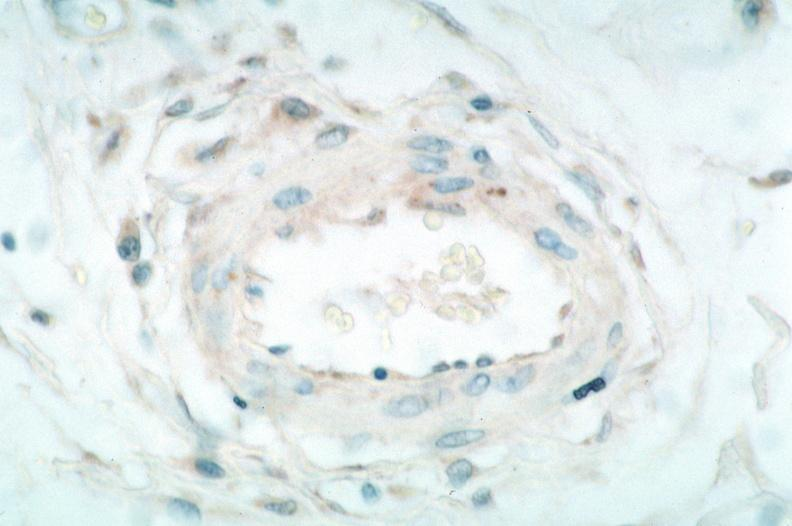what is present?
Answer the question using a single word or phrase. Vasculature 